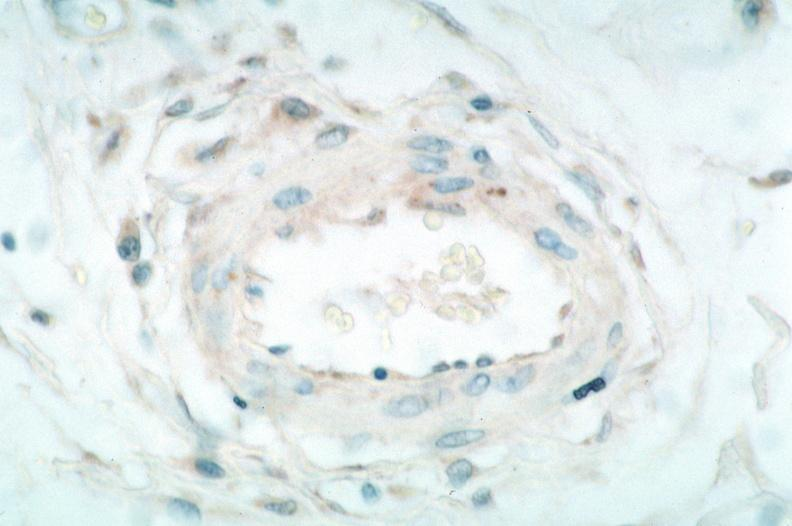what is present?
Answer the question using a single word or phrase. Vasculature 